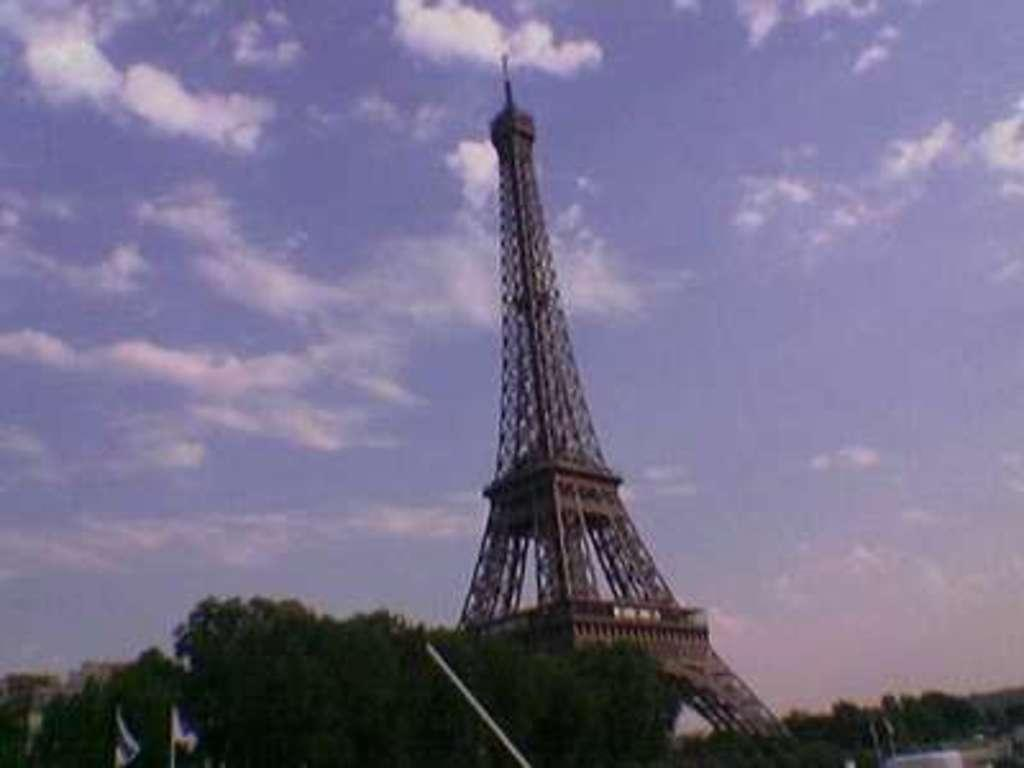What is the main structure in the middle of the image? There is an Eiffel tower in the middle of the image. What can be seen in the sky at the top of the image? The sky with clouds is visible at the top of the image. What type of vegetation is on the left side of the image? There are trees on the left side of the image beside the tower. What type of cap is the Eiffel tower wearing in the image? The Eiffel tower is not wearing a cap in the image; it is a structure without clothing or accessories. 